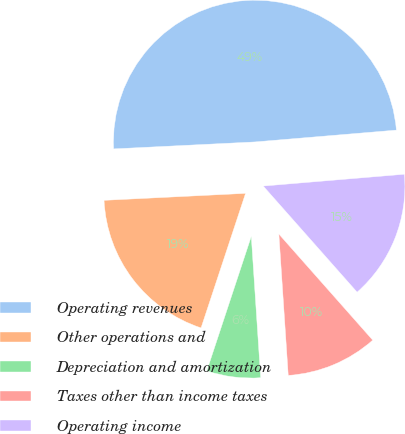Convert chart to OTSL. <chart><loc_0><loc_0><loc_500><loc_500><pie_chart><fcel>Operating revenues<fcel>Other operations and<fcel>Depreciation and amortization<fcel>Taxes other than income taxes<fcel>Operating income<nl><fcel>49.45%<fcel>19.13%<fcel>6.14%<fcel>10.47%<fcel>14.8%<nl></chart> 